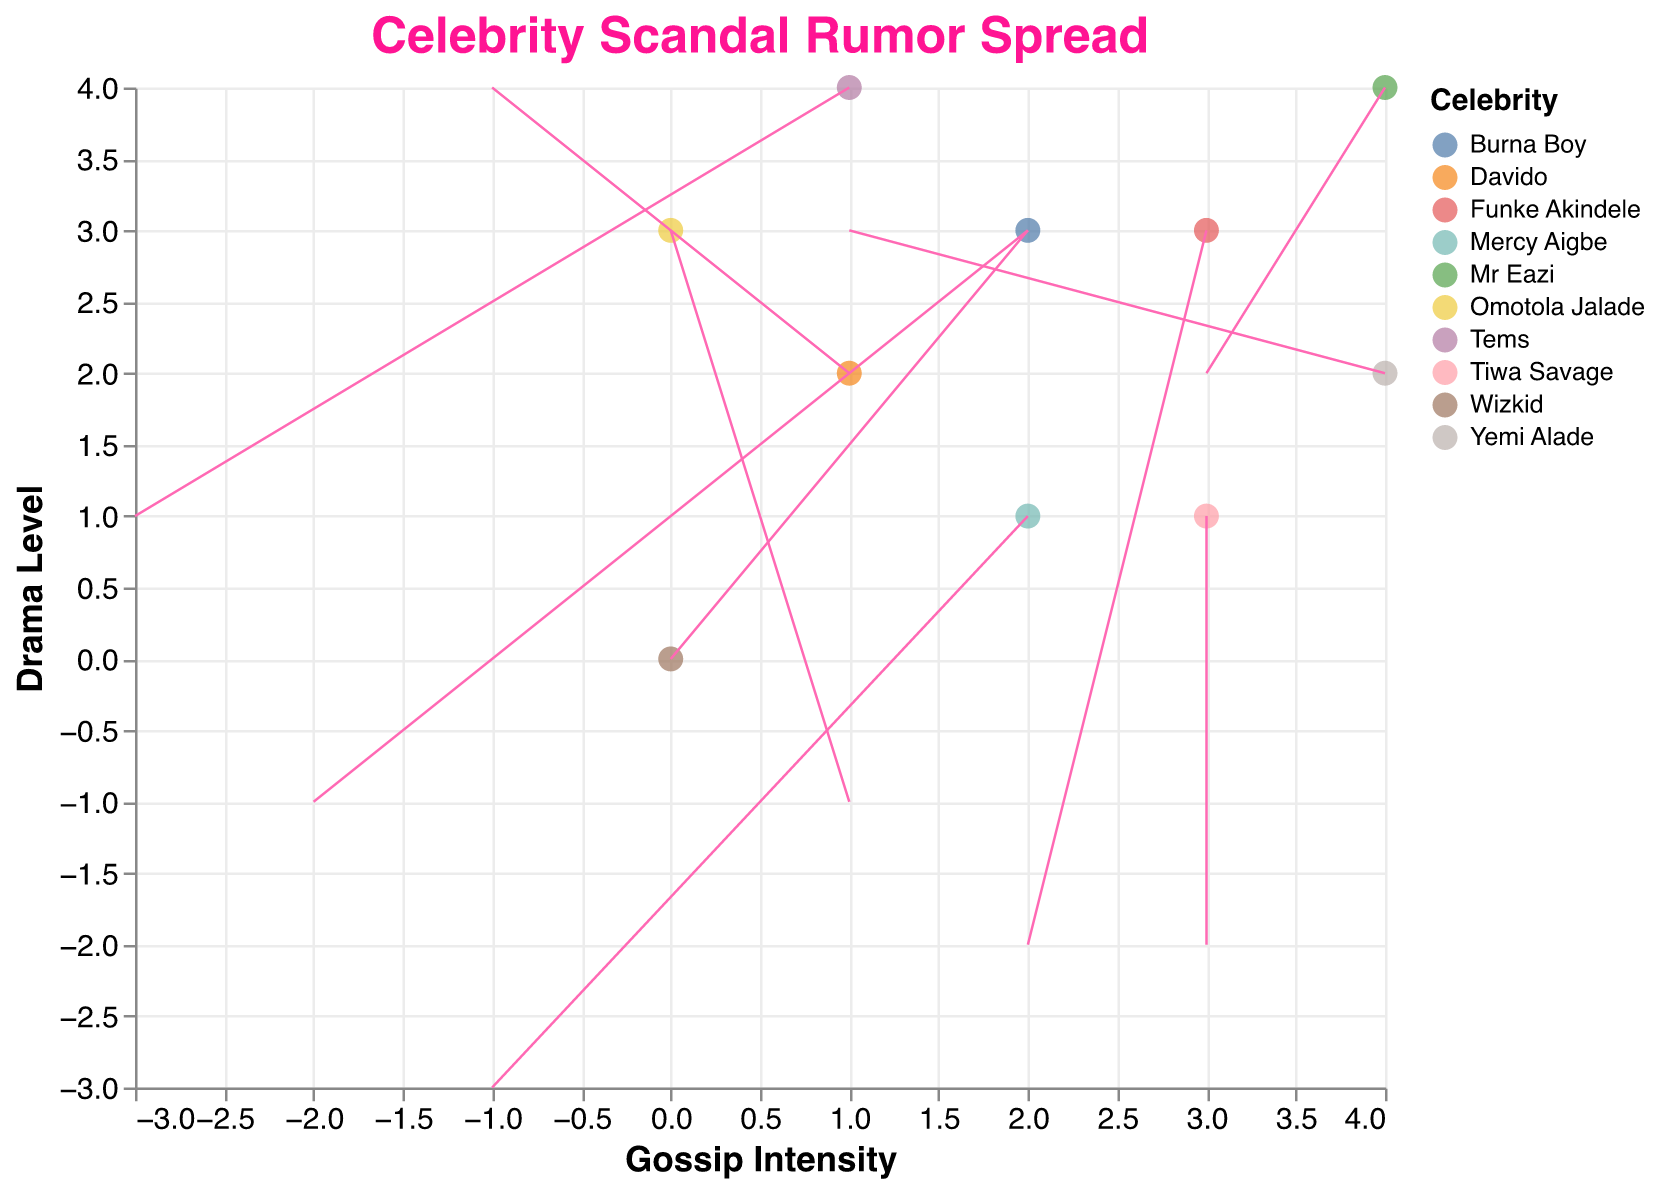who has the highest drama level? To determine the celebrity with the highest drama level, we need to check the y-coordinate values. The highest y-coordinate in the figure is 4, corresponding to Tems and Mr Eazi.
Answer: Tems, Mr Eazi Which celebrity’s scandal spreads the fastest and in which direction? The magnitude value represents the spread speed. Wizkid has the highest magnitude of 5. The direction is indicated by the vector (u, v); for Wizkid, it's (2, 3).
Answer: Wizkid, direction (2, 3) What’s the relationship between gossip intensity and scandal magnitude for Mercy Aigbe? Mercy Aigbe is at (2, 1). We need to refer to the x-coordinate for gossip intensity and find the 'magnitude' field, which is 3. There's no direct relation between them stated; however, her magnitude is 3, and gossip intensity is 2.
Answer: Gossip intensity is 2, magnitude is 3 Which celebrities have a negative u component? The u component represents horizontal movement. Negative u values indicate leftward spread. The celebrities with negative u values are Davido, Burna Boy, Tems, and Mercy Aigbe.
Answer: Davido, Burna Boy, Tems, Mercy Aigbe Compare the horizontal spread of rumors between Tiwa Savage and Funke Akindele. Who has a stronger horizontal component? Tiwa Savage has u = 3, and Funke Akindele has u = 2. Comparatively, Tiwa Savage has a stronger horizontal (positive) component.
Answer: Tiwa Savage Which celebrity is associated with the smallest scandal magnitude? The smallest magnitude value is 1, which corresponds to Omotola Jalade.
Answer: Omotola Jalade Identify the celebrity with the steepest vertical spread. The steepest vertical spread can be determined by looking at the v value. Davido has the highest vertical component of v = 4.
Answer: Davido Among Mr Eazi and Tems, who has a greater total vector length and what does it indicate about the scandal spread? To compare their total vector length, calculate the magnitude: for Mr Eazi (3, 2) is sqrt(3^2 + 2^2) = 3.6 approximately, and for Tems (-3, 1) is sqrt((-3)^2 + 1^2) = 3.2 approximately. Mr Eazi's vector length is greater, indicating his scandal spread is faster.
Answer: Mr Eazi Which celebrities' rumors travel upward (positive v values)? To determine this, find the celebrities with positive v values: Wizkid, Davido, and Yemi Alade.
Answer: Wizkid, Davido, Yemi Alade 